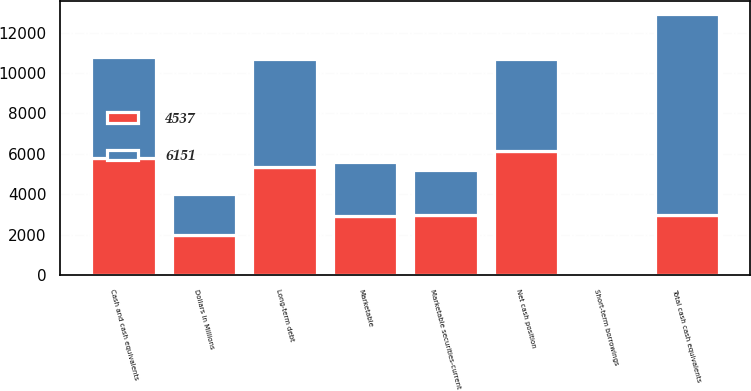<chart> <loc_0><loc_0><loc_500><loc_500><stacked_bar_chart><ecel><fcel>Dollars in Millions<fcel>Cash and cash equivalents<fcel>Marketable securities-current<fcel>Marketable<fcel>Total cash cash equivalents<fcel>Short-term borrowings<fcel>Long-term debt<fcel>Net cash position<nl><fcel>4537<fcel>2011<fcel>5776<fcel>2957<fcel>2909<fcel>2957<fcel>115<fcel>5376<fcel>6151<nl><fcel>6151<fcel>2010<fcel>5033<fcel>2268<fcel>2681<fcel>9982<fcel>117<fcel>5328<fcel>4537<nl></chart> 